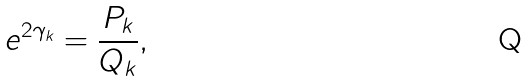<formula> <loc_0><loc_0><loc_500><loc_500>e ^ { 2 \gamma _ { k } } = \frac { P _ { k } } { Q _ { k } } ,</formula> 